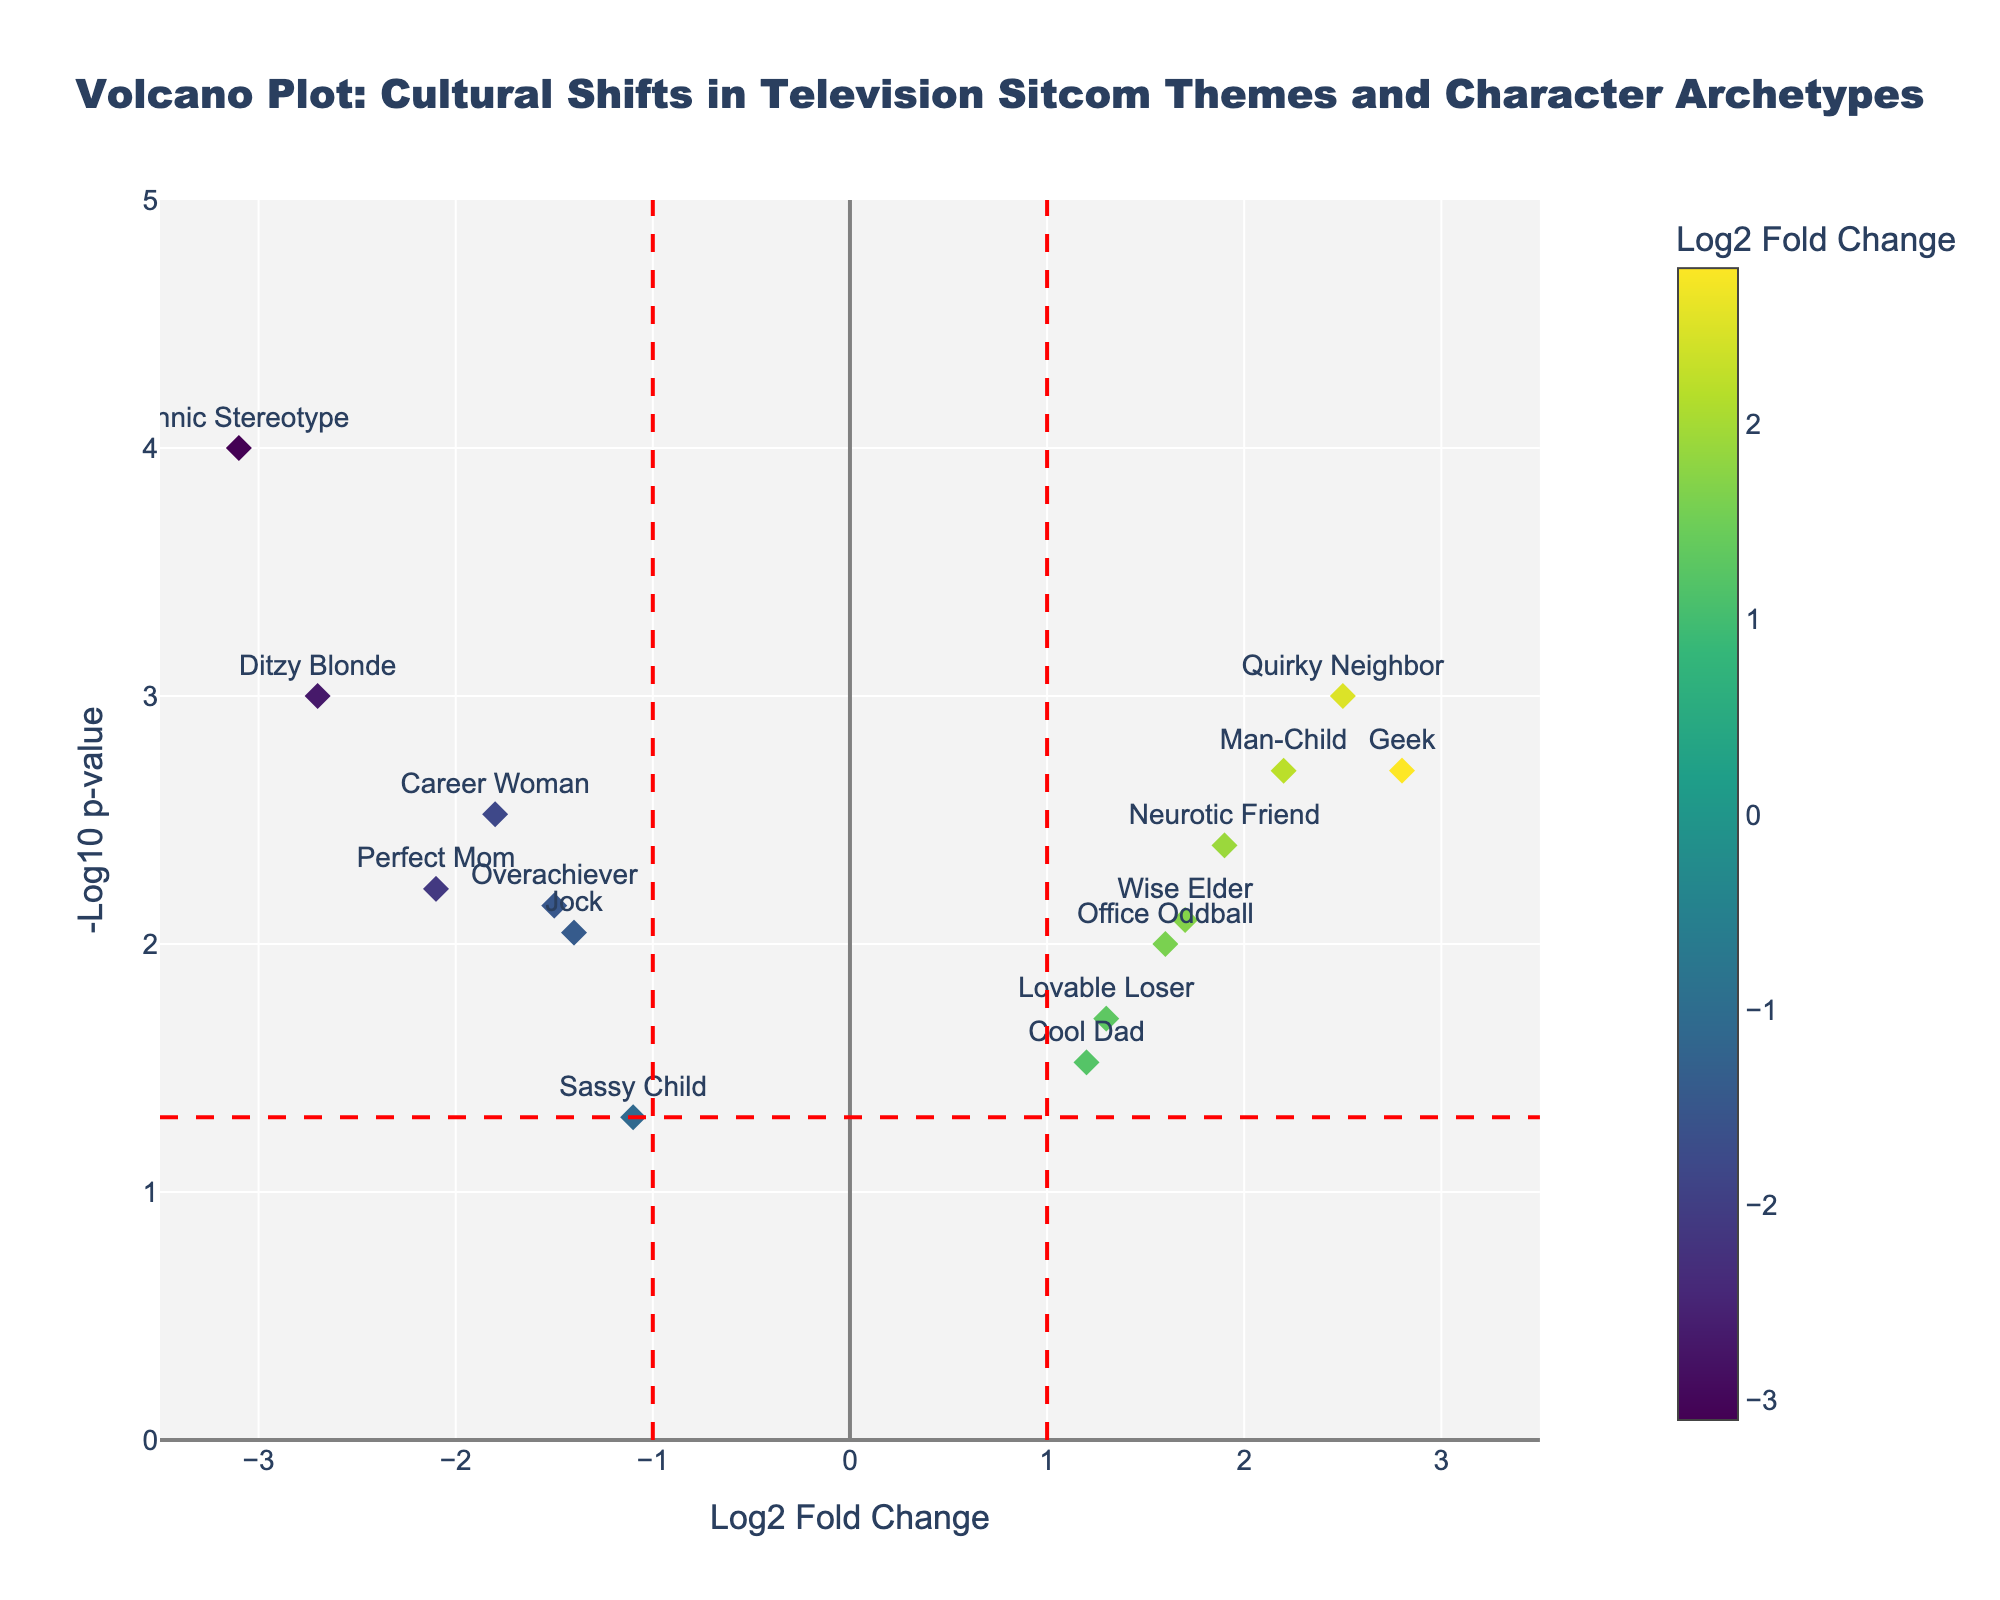What is the title of the figure? The figure's title is typically located at the top and is usually prominent and descriptive of the visualized data. Here, it states "Volcano Plot: Cultural Shifts in Television Sitcom Themes and Character Archetypes".
Answer: Volcano Plot: Cultural Shifts in Television Sitcom Themes and Character Archetypes How many character archetypes show a significant shift at p-value < 0.05? By looking at the vertical position of the points in the figure, any point above the horizontal red dashed line indicates a significant p-value (< 0.05).
Answer: 13 Which character archetype has the highest positive log2 fold change? The highest positive log2 fold change is the rightmost point on the x-axis. This represents the "Geek" character archetype with a log2 fold change of 2.8.
Answer: Geek Which character archetype has the lowest p-value? The lowest p-value corresponds to the highest point on the y-axis. The "Ethnic Stereotype" archetype has the lowest p-value as it is the highest point on the plot.
Answer: Ethnic Stereotype Which character archetype shows the most substantial negative shift in theme? The most significant negative shift in theme is represented by the leftmost point on the x-axis, which is the "Ethnic Stereotype" archetype with a log2 fold change of -3.1.
Answer: Ethnic Stereotype What is the log2 fold change for the "Perfect Mom" character archetype? Find the "Perfect Mom" data point by referring to its x-coordinate, which represents the log2 fold change. The "Perfect Mom" has a log2 fold change of -2.1.
Answer: -2.1 Which themes have a log2 fold change greater than 2? By examining the points to the right of x=2, we see both "Quirky Neighbor" and "Geek" exceed this threshold.
Answer: Quirky Neighbor, Geek How does the "Ditzy Blonde" compare to the "Career Woman" in log2 fold change? To compare these archetypes, we observe their x-positions. The "Ditzy Blonde" is at -2.7, and the "Career Woman" is at -1.8, meaning the "Ditzy Blonde" has a more considerable negative shift.
Answer: Ditzy Blonde is more negative Which character archetypes have been impacted by themes related to personal growth? Look at the hover information or positions of points related to "Personal Growth". The "Lovable Loser" fits this theme.
Answer: Lovable Loser How does -log10(p-value) for the "Man-Child" character archetype compare to that of the "Cool Dad"? Compare their vertical positions. "Man-Child" has a higher -log10(p-value) than "Cool Dad", indicating a more significant shift in theme.
Answer: Man-Child is higher 